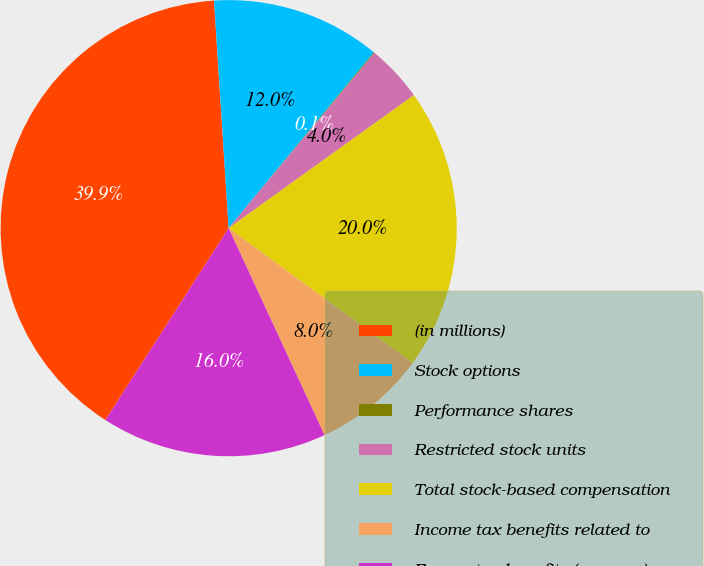Convert chart. <chart><loc_0><loc_0><loc_500><loc_500><pie_chart><fcel>(in millions)<fcel>Stock options<fcel>Performance shares<fcel>Restricted stock units<fcel>Total stock-based compensation<fcel>Income tax benefits related to<fcel>Excess tax benefits (expense)<nl><fcel>39.89%<fcel>12.01%<fcel>0.06%<fcel>4.04%<fcel>19.98%<fcel>8.03%<fcel>15.99%<nl></chart> 